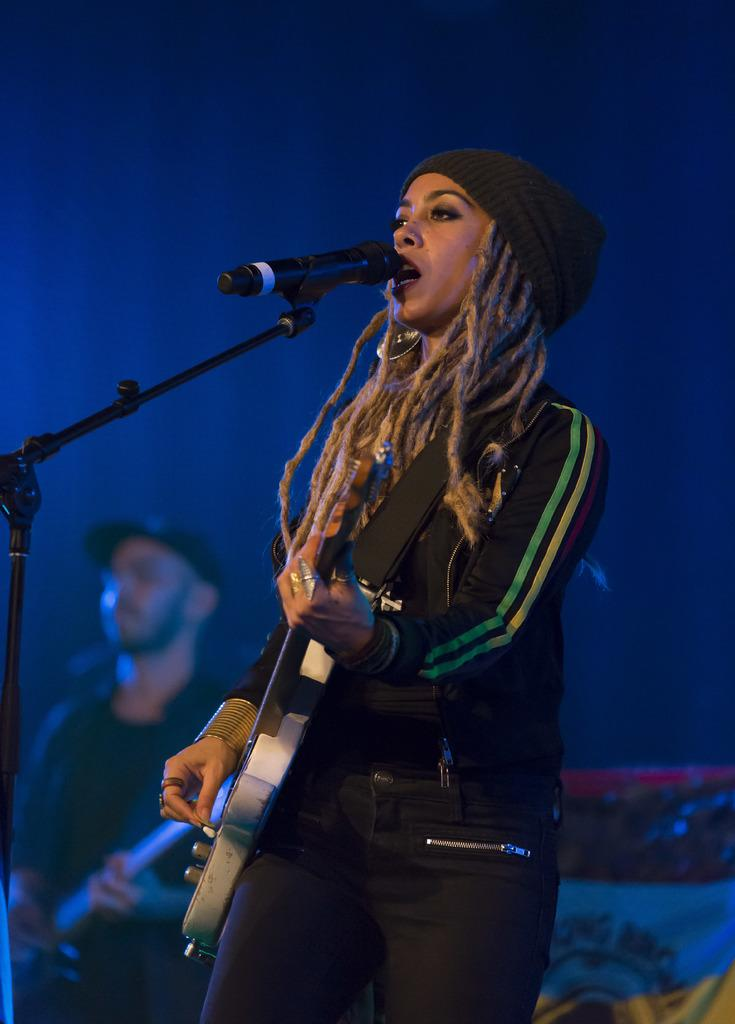Who is the main subject in the image? There is a woman in the image. What is the woman doing in the image? The woman is singing and playing a guitar. What object is in front of the woman? There is a microphone in front of the woman. Can you see any stamps on the table in the image? There is no table or stamps present in the image. What type of kite is the woman flying in the image? There is no kite in the image; the woman is singing and playing a guitar. 